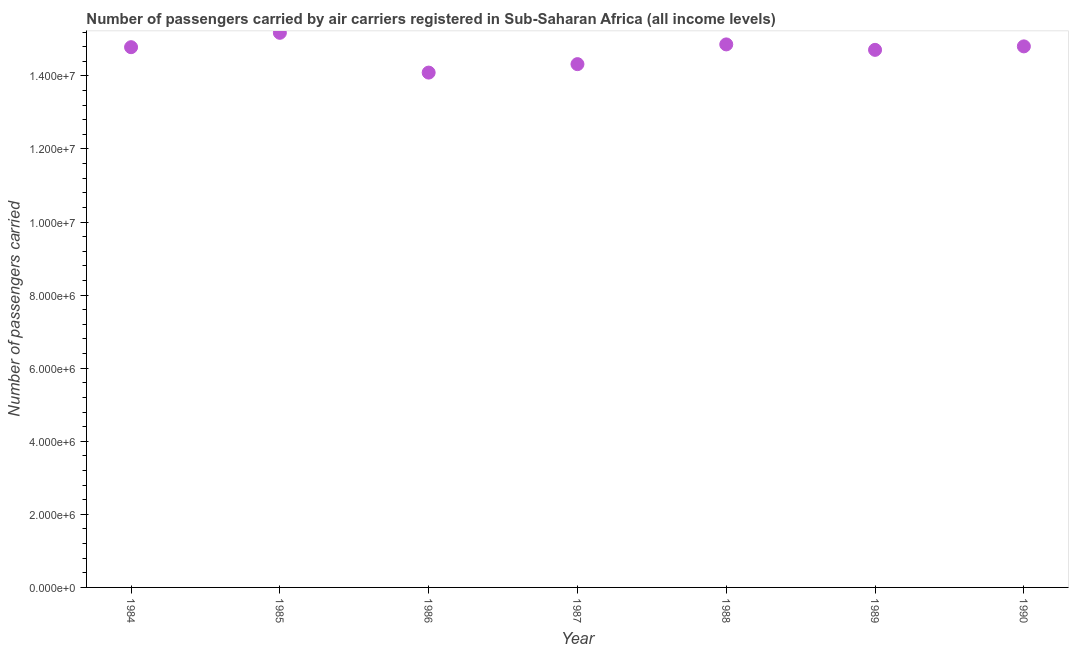What is the number of passengers carried in 1989?
Provide a succinct answer. 1.47e+07. Across all years, what is the maximum number of passengers carried?
Provide a succinct answer. 1.52e+07. Across all years, what is the minimum number of passengers carried?
Offer a terse response. 1.41e+07. In which year was the number of passengers carried maximum?
Offer a terse response. 1985. In which year was the number of passengers carried minimum?
Make the answer very short. 1986. What is the sum of the number of passengers carried?
Make the answer very short. 1.03e+08. What is the difference between the number of passengers carried in 1984 and 1989?
Make the answer very short. 7.30e+04. What is the average number of passengers carried per year?
Ensure brevity in your answer.  1.47e+07. What is the median number of passengers carried?
Provide a succinct answer. 1.48e+07. What is the ratio of the number of passengers carried in 1985 to that in 1989?
Offer a very short reply. 1.03. Is the difference between the number of passengers carried in 1986 and 1989 greater than the difference between any two years?
Make the answer very short. No. What is the difference between the highest and the second highest number of passengers carried?
Your answer should be very brief. 3.17e+05. What is the difference between the highest and the lowest number of passengers carried?
Keep it short and to the point. 1.09e+06. In how many years, is the number of passengers carried greater than the average number of passengers carried taken over all years?
Your answer should be very brief. 5. How many dotlines are there?
Provide a succinct answer. 1. How many years are there in the graph?
Ensure brevity in your answer.  7. What is the difference between two consecutive major ticks on the Y-axis?
Your response must be concise. 2.00e+06. Does the graph contain any zero values?
Your answer should be compact. No. What is the title of the graph?
Ensure brevity in your answer.  Number of passengers carried by air carriers registered in Sub-Saharan Africa (all income levels). What is the label or title of the Y-axis?
Make the answer very short. Number of passengers carried. What is the Number of passengers carried in 1984?
Offer a very short reply. 1.48e+07. What is the Number of passengers carried in 1985?
Keep it short and to the point. 1.52e+07. What is the Number of passengers carried in 1986?
Offer a terse response. 1.41e+07. What is the Number of passengers carried in 1987?
Your answer should be very brief. 1.43e+07. What is the Number of passengers carried in 1988?
Keep it short and to the point. 1.49e+07. What is the Number of passengers carried in 1989?
Offer a terse response. 1.47e+07. What is the Number of passengers carried in 1990?
Your response must be concise. 1.48e+07. What is the difference between the Number of passengers carried in 1984 and 1985?
Offer a terse response. -3.93e+05. What is the difference between the Number of passengers carried in 1984 and 1986?
Your answer should be compact. 6.95e+05. What is the difference between the Number of passengers carried in 1984 and 1987?
Your answer should be compact. 4.64e+05. What is the difference between the Number of passengers carried in 1984 and 1988?
Your answer should be very brief. -7.61e+04. What is the difference between the Number of passengers carried in 1984 and 1989?
Your response must be concise. 7.30e+04. What is the difference between the Number of passengers carried in 1984 and 1990?
Your response must be concise. -2.22e+04. What is the difference between the Number of passengers carried in 1985 and 1986?
Ensure brevity in your answer.  1.09e+06. What is the difference between the Number of passengers carried in 1985 and 1987?
Provide a succinct answer. 8.57e+05. What is the difference between the Number of passengers carried in 1985 and 1988?
Your response must be concise. 3.17e+05. What is the difference between the Number of passengers carried in 1985 and 1989?
Your answer should be compact. 4.66e+05. What is the difference between the Number of passengers carried in 1985 and 1990?
Your answer should be compact. 3.71e+05. What is the difference between the Number of passengers carried in 1986 and 1987?
Make the answer very short. -2.32e+05. What is the difference between the Number of passengers carried in 1986 and 1988?
Make the answer very short. -7.71e+05. What is the difference between the Number of passengers carried in 1986 and 1989?
Offer a terse response. -6.22e+05. What is the difference between the Number of passengers carried in 1986 and 1990?
Make the answer very short. -7.18e+05. What is the difference between the Number of passengers carried in 1987 and 1988?
Offer a very short reply. -5.40e+05. What is the difference between the Number of passengers carried in 1987 and 1989?
Your answer should be very brief. -3.91e+05. What is the difference between the Number of passengers carried in 1987 and 1990?
Your answer should be compact. -4.86e+05. What is the difference between the Number of passengers carried in 1988 and 1989?
Your answer should be very brief. 1.49e+05. What is the difference between the Number of passengers carried in 1988 and 1990?
Offer a very short reply. 5.39e+04. What is the difference between the Number of passengers carried in 1989 and 1990?
Ensure brevity in your answer.  -9.52e+04. What is the ratio of the Number of passengers carried in 1984 to that in 1986?
Your answer should be very brief. 1.05. What is the ratio of the Number of passengers carried in 1984 to that in 1987?
Make the answer very short. 1.03. What is the ratio of the Number of passengers carried in 1984 to that in 1988?
Your answer should be compact. 0.99. What is the ratio of the Number of passengers carried in 1984 to that in 1990?
Your answer should be very brief. 1. What is the ratio of the Number of passengers carried in 1985 to that in 1986?
Offer a terse response. 1.08. What is the ratio of the Number of passengers carried in 1985 to that in 1987?
Provide a short and direct response. 1.06. What is the ratio of the Number of passengers carried in 1985 to that in 1989?
Keep it short and to the point. 1.03. What is the ratio of the Number of passengers carried in 1986 to that in 1988?
Offer a terse response. 0.95. What is the ratio of the Number of passengers carried in 1986 to that in 1989?
Offer a terse response. 0.96. What is the ratio of the Number of passengers carried in 1988 to that in 1990?
Give a very brief answer. 1. What is the ratio of the Number of passengers carried in 1989 to that in 1990?
Ensure brevity in your answer.  0.99. 